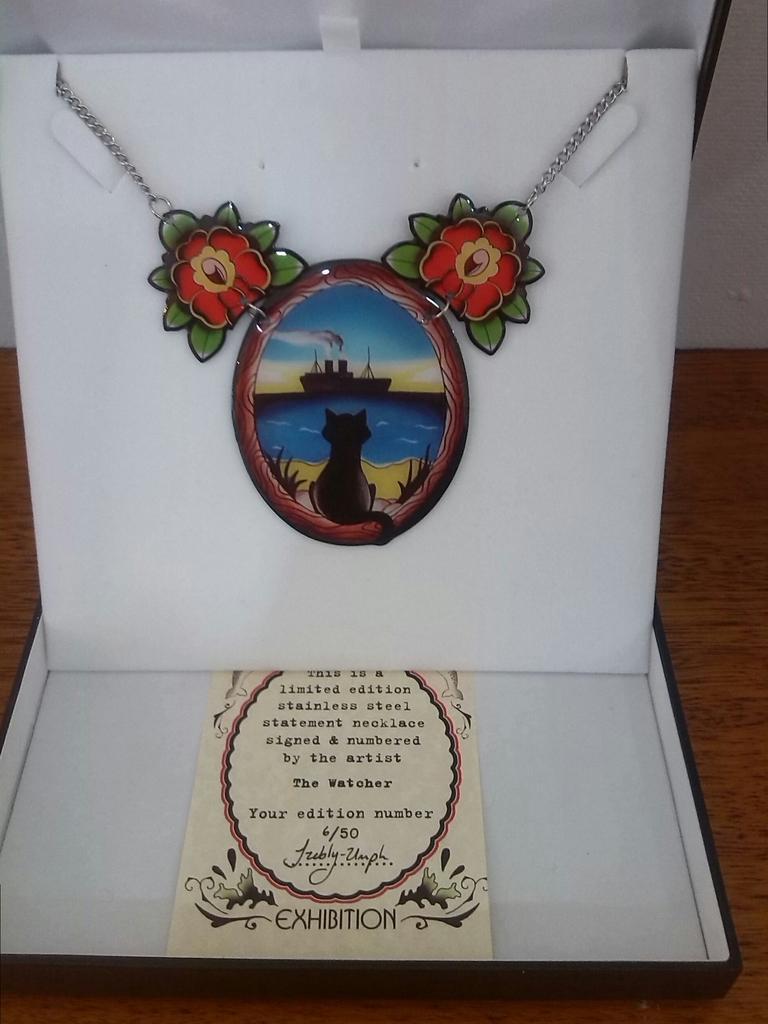Please provide a concise description of this image. As we can see in the image there is a table. On table there is a box. In box there is a chain and locket. In locket there is drawing of cat, water and boat. In the background there is a white color wall. 